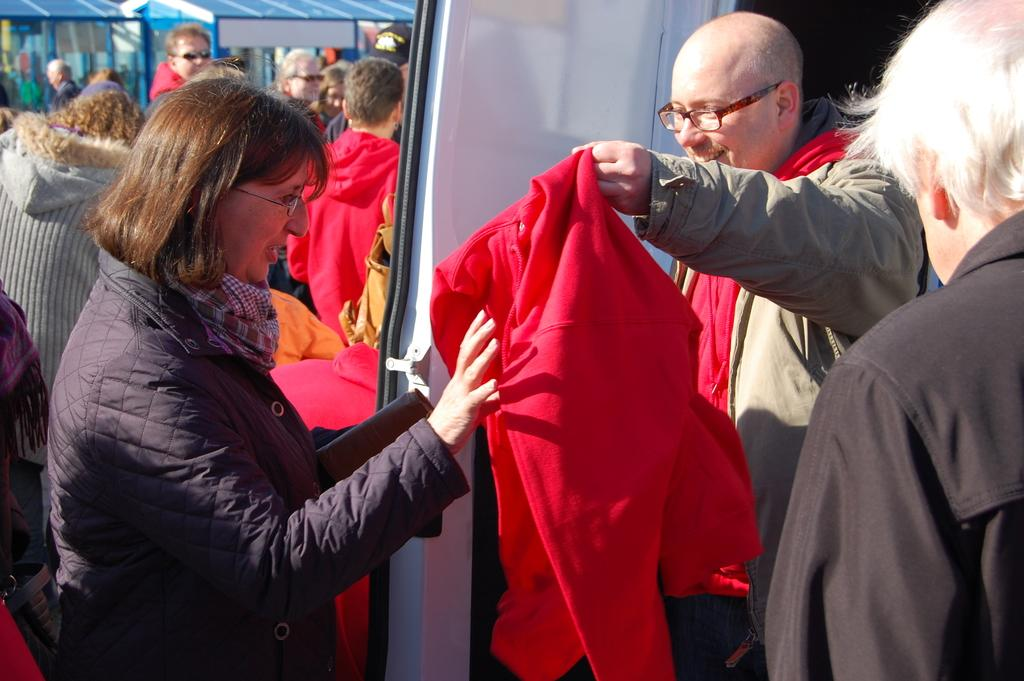Who is present in the image? There is a person in the image. What is the person wearing? The person is wearing a spectacle. What is the person holding? The person is holding a jacket. What can be seen in the background of the image? There are people and objects in the background of the image. What type of cherry is the person eating in the image? There is no cherry present in the image, so it cannot be determined if the person is eating a cherry. 